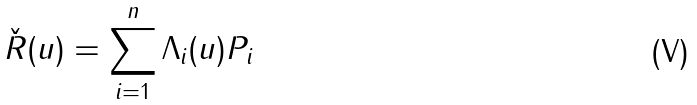Convert formula to latex. <formula><loc_0><loc_0><loc_500><loc_500>\check { R } ( u ) = \sum _ { i = 1 } ^ { n } \Lambda _ { i } ( u ) P _ { i }</formula> 